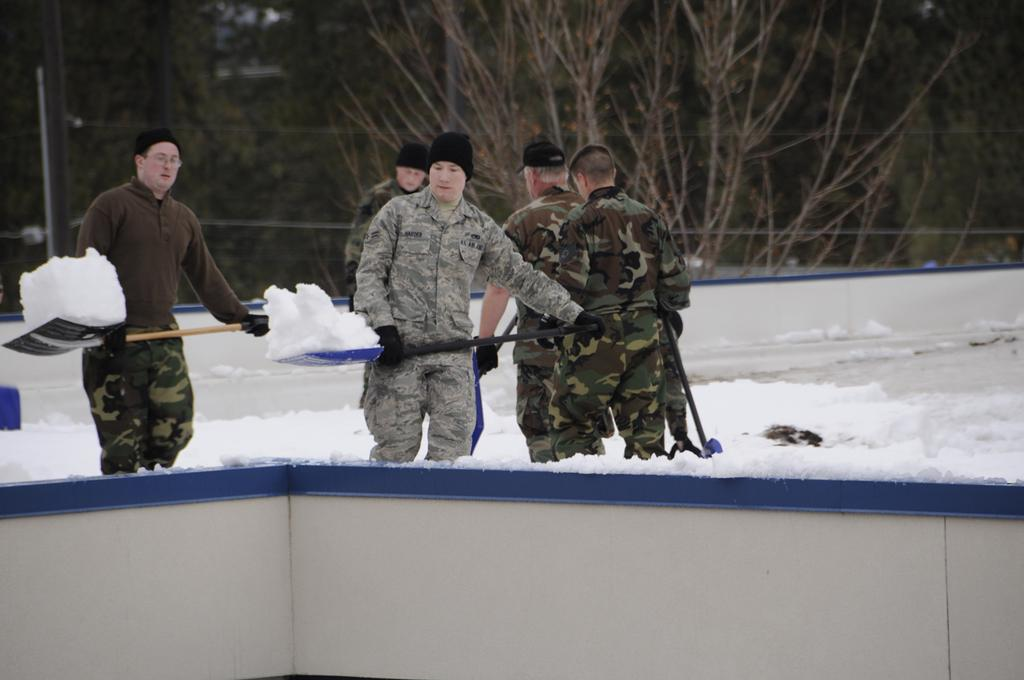How many people are in the image? There are people in the image. What are two people doing in the image? Two people are carrying snow with shovels. What can be seen in the background of the image? There is a wall visible in the image. What type of gun can be seen in the hands of the people in the image? There are no guns present in the image; the people are carrying snow with shovels. How many tomatoes are visible on the wall in the image? There are no tomatoes present in the image; the wall is the only visible feature in the background. 